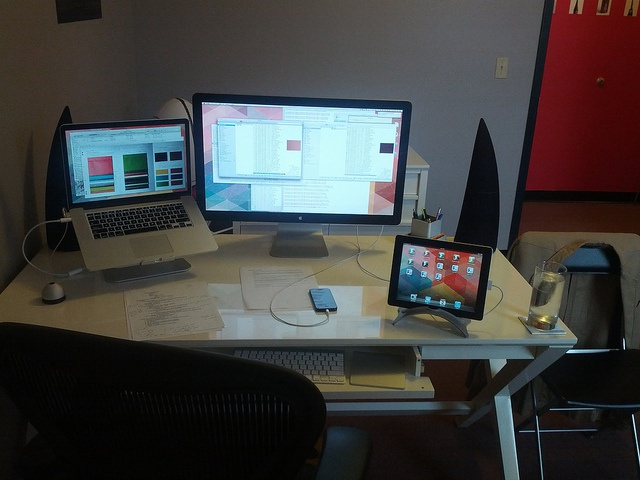Describe the objects in this image and their specific colors. I can see chair in black and gray tones, tv in black, lightblue, and navy tones, laptop in black, gray, and lightblue tones, chair in black, blue, and darkblue tones, and tv in black, brown, blue, and gray tones in this image. 